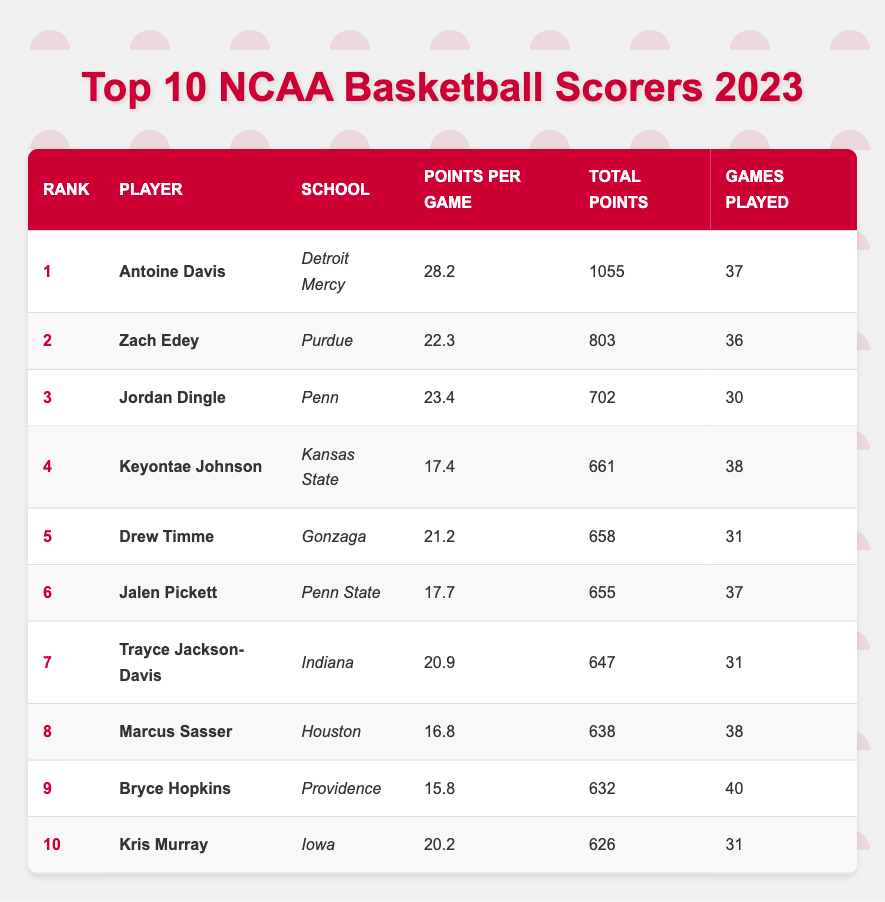What is the highest points per game recorded by a player in 2023? The highest points per game in the table is found in the "Points Per Game" column for Antoine Davis at rank 1, which is 28.2.
Answer: 28.2 Which player scored the least total points among the top 10? To determine the least total points, we compare the "Total Points" column, where Bryce Hopkins has the lowest total points of 632.
Answer: 632 How many games did Antoine Davis play to score his points? Antoine Davis is listed under the "Games Played" column at rank 1, showing that he played 37 games.
Answer: 37 What is the total number of points scored by the top three players combined? We add the total points of the top three players: Antoine Davis (1055) + Zach Edey (803) + Jordan Dingle (702) = 2560.
Answer: 2560 Is Zach Edey from a school in the Big Ten Conference? Purdue, where Zach Edey plays, is a member of the Big Ten Conference. Therefore, the answer is yes.
Answer: Yes What is the average points per game of players ranked 4 to 6? For players ranked 4 to 6, their points per game are as follows: Keyontae Johnson (17.4), Drew Timme (21.2), and Jalen Pickett (17.7). To find the average, we sum these scores: 17.4 + 21.2 + 17.7 = 56.3, then divide by 3, which gives 56.3 / 3 = 18.77.
Answer: 18.77 Who has more total points, Keyontae Johnson or Jalen Pickett? Looking at the "Total Points" column, Keyontae Johnson has 661 points while Jalen Pickett has 655 points. Comparing the two shows that Keyontae Johnson has more total points.
Answer: Keyontae Johnson What is the difference in points scored between the player with the highest total points and the one with the lowest? The highest total points is Antoine Davis with 1055, and the lowest is Bryce Hopkins with 632. The difference is calculated as 1055 - 632 = 423.
Answer: 423 How many players have a points per game of 20 or more? The players with a points per game of 20 or more are Antoine Davis (28.2), Zach Edey (22.3), Jordan Dingle (23.4), and Trayce Jackson-Davis (20.9). This totals to 4 players.
Answer: 4 